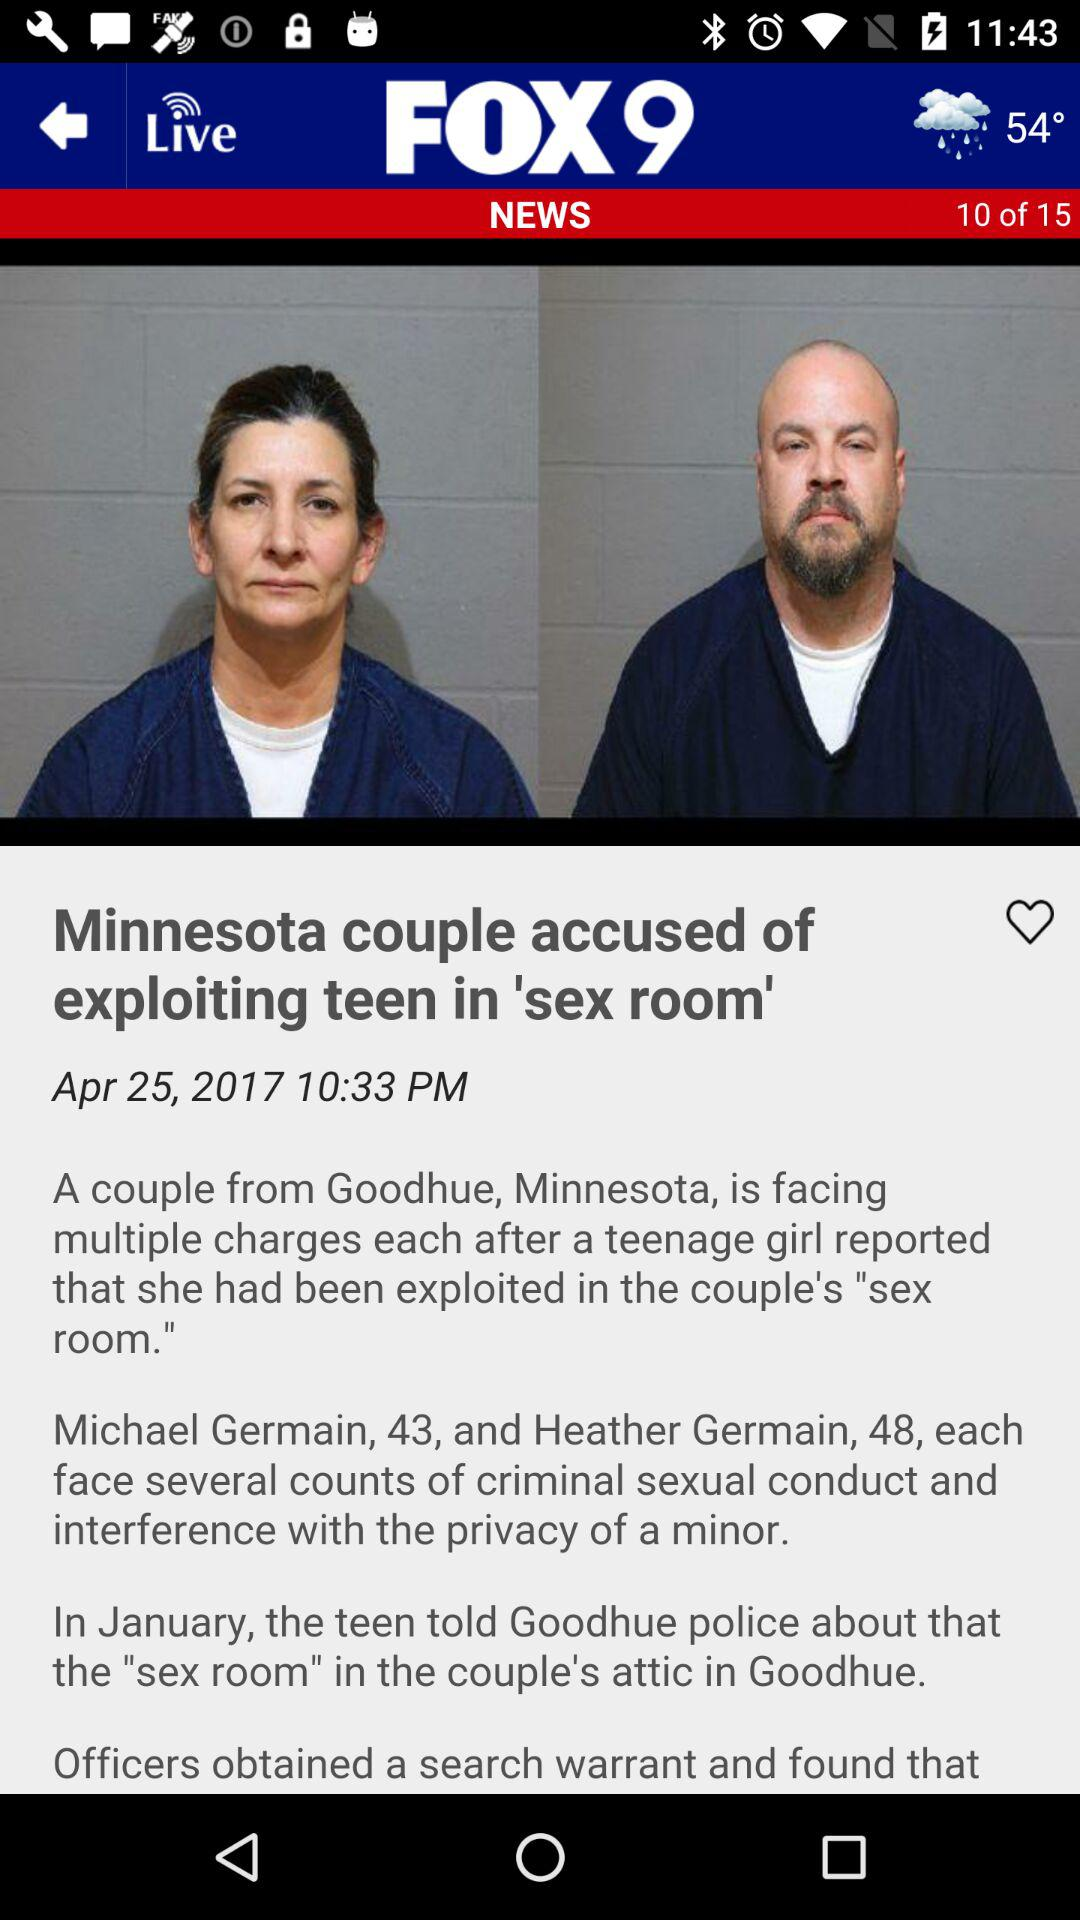Which slide number is currently shown? Currently, the shown slide number is 10. 